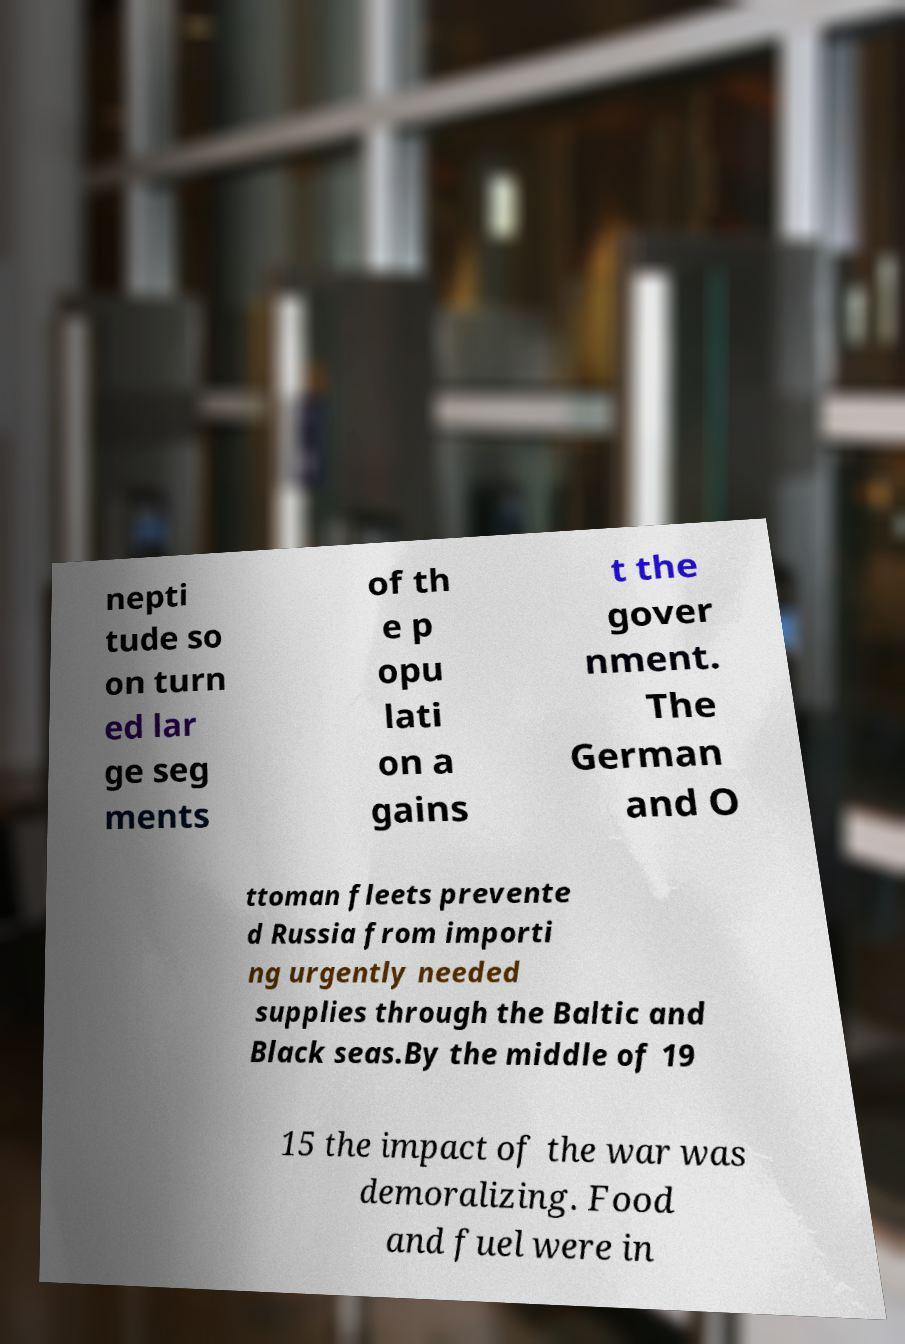Please identify and transcribe the text found in this image. nepti tude so on turn ed lar ge seg ments of th e p opu lati on a gains t the gover nment. The German and O ttoman fleets prevente d Russia from importi ng urgently needed supplies through the Baltic and Black seas.By the middle of 19 15 the impact of the war was demoralizing. Food and fuel were in 